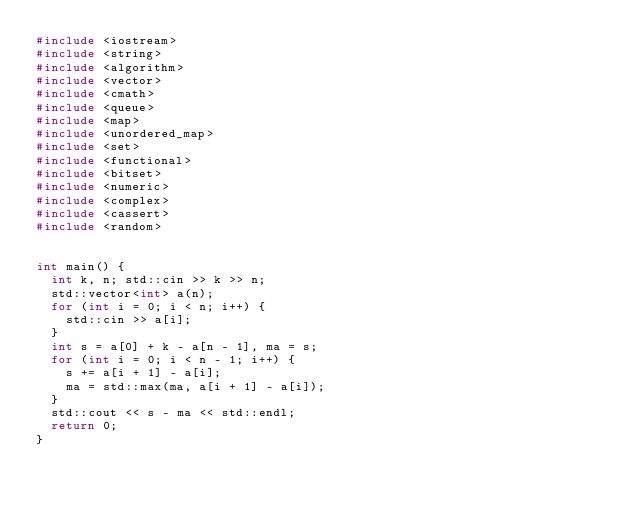<code> <loc_0><loc_0><loc_500><loc_500><_C++_>#include <iostream>
#include <string>
#include <algorithm>
#include <vector>
#include <cmath>
#include <queue>
#include <map>
#include <unordered_map>
#include <set>
#include <functional>
#include <bitset>
#include <numeric>
#include <complex>
#include <cassert>
#include <random>


int main() {
	int k, n; std::cin >> k >> n;
	std::vector<int> a(n);
	for (int i = 0; i < n; i++) {
		std::cin >> a[i];
	}
	int s = a[0] + k - a[n - 1], ma = s;
	for (int i = 0; i < n - 1; i++) {
		s += a[i + 1] - a[i];
		ma = std::max(ma, a[i + 1] - a[i]);
	}
	std::cout << s - ma << std::endl;
	return 0;
}
</code> 